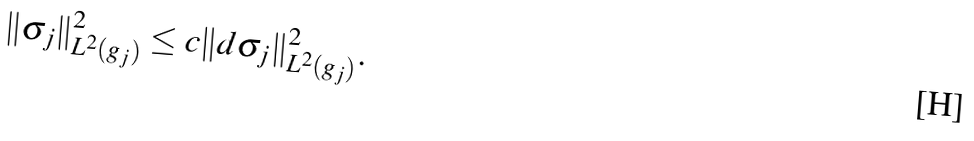<formula> <loc_0><loc_0><loc_500><loc_500>\| \sigma _ { j } \| ^ { 2 } _ { L ^ { 2 } ( g _ { j } ) } \leq c \| d \sigma _ { j } \| ^ { 2 } _ { L ^ { 2 } ( g _ { j } ) } .</formula> 